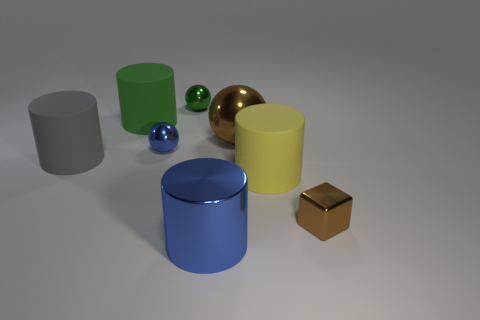Subtract all tiny spheres. How many spheres are left? 1 Add 1 small shiny blocks. How many objects exist? 9 Subtract 1 blocks. How many blocks are left? 0 Subtract all brown spheres. How many spheres are left? 2 Add 7 tiny gray matte balls. How many tiny gray matte balls exist? 7 Subtract 1 brown spheres. How many objects are left? 7 Subtract all blocks. How many objects are left? 7 Subtract all purple cylinders. Subtract all green spheres. How many cylinders are left? 4 Subtract all gray cylinders. How many blue balls are left? 1 Subtract all small purple rubber objects. Subtract all big blue shiny objects. How many objects are left? 7 